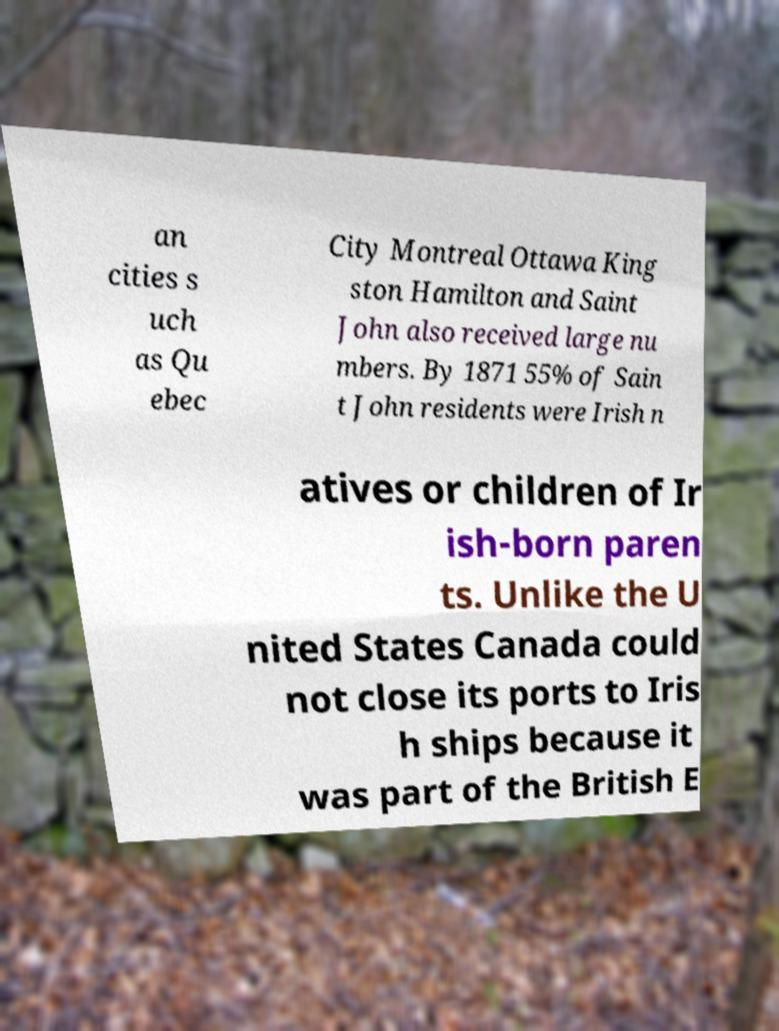What messages or text are displayed in this image? I need them in a readable, typed format. an cities s uch as Qu ebec City Montreal Ottawa King ston Hamilton and Saint John also received large nu mbers. By 1871 55% of Sain t John residents were Irish n atives or children of Ir ish-born paren ts. Unlike the U nited States Canada could not close its ports to Iris h ships because it was part of the British E 